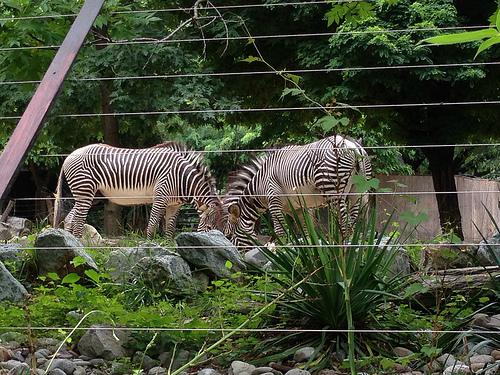Question: what are the zebras doing?
Choices:
A. Eating.
B. Drinking.
C. Sleeping.
D. Washing themselves.
Answer with the letter. Answer: A Question: what animal is pictured?
Choices:
A. Giraffes.
B. Zebras.
C. Elephants.
D. Monkeys.
Answer with the letter. Answer: B Question: when was the photo taken?
Choices:
A. Morning.
B. Evening.
C. Dawn.
D. Dusk.
Answer with the letter. Answer: A Question: why is there a fence?
Choices:
A. To keep the cows in.
B. To keep the sheep in.
C. Safety.
D. To keep the goats in.
Answer with the letter. Answer: C 